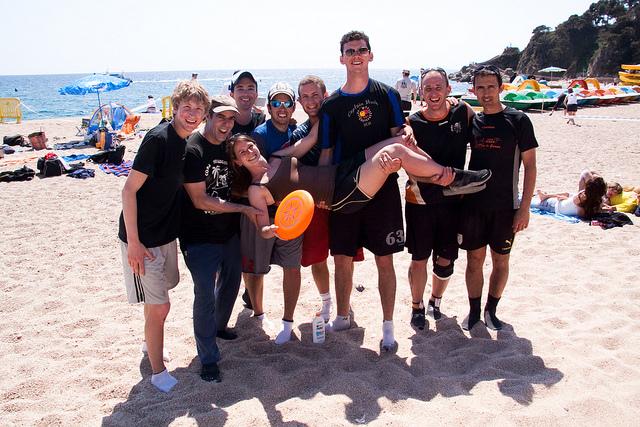How many people have sunglasses over their eyes?
Write a very short answer. 2. What is the color of the frisbee?
Quick response, please. Orange. Where are these people standing?
Be succinct. Beach. 